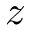Convert formula to latex. <formula><loc_0><loc_0><loc_500><loc_500>z</formula> 